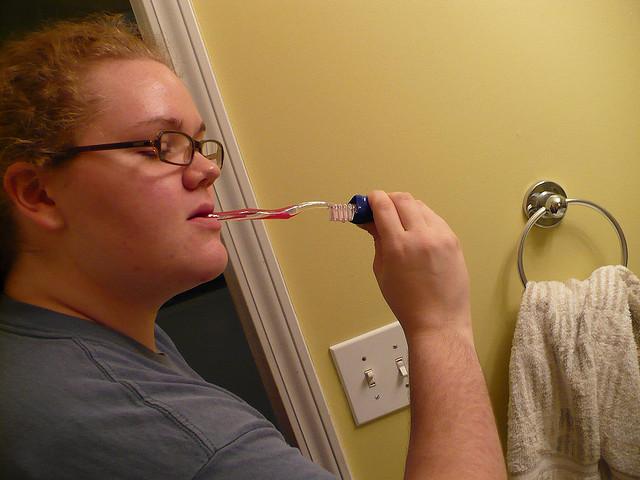What kind of switch is on the wall?
Give a very brief answer. Light. What is in the woman's mouth?
Short answer required. Toothbrush. Is the toothbrush in her mouth the right way?
Answer briefly. No. 